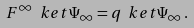<formula> <loc_0><loc_0><loc_500><loc_500>F ^ { \infty } \ k e t { \Psi _ { \infty } } = q \ k e t { \Psi _ { \infty } } \, .</formula> 